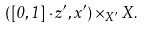Convert formula to latex. <formula><loc_0><loc_0><loc_500><loc_500>\left ( \left [ 0 , 1 \right ] \cdot z ^ { \prime } , x ^ { \prime } \right ) \times _ { X ^ { \prime } } X .</formula> 